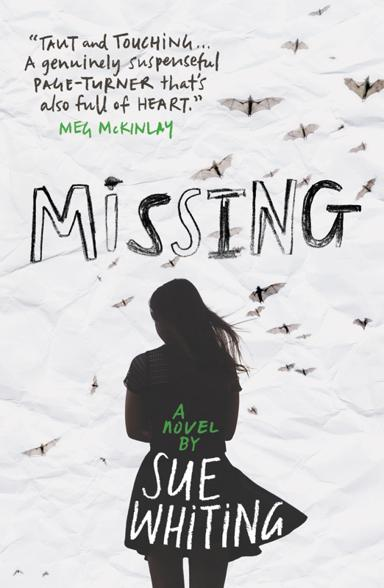What is the name of the novel mentioned in the image?
 The name of the novel is "Missing" by Sue Whiting. What kind of praise does the novel receive in the image? The novel is praised as being "Taut and Touching," "genuinely suspenseful," and "a page-turner that's also full of heart," according to Meg McKinlay. 